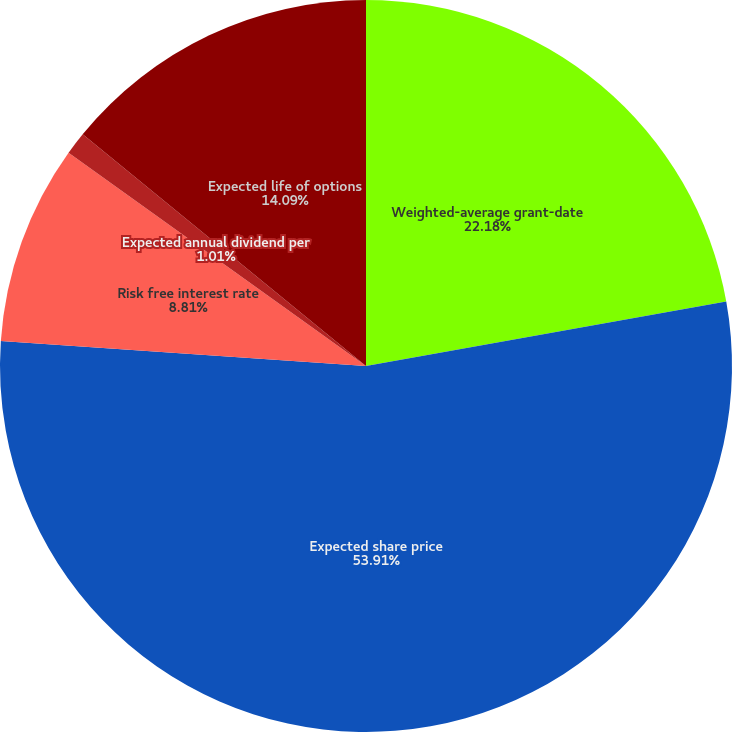<chart> <loc_0><loc_0><loc_500><loc_500><pie_chart><fcel>Weighted-average grant-date<fcel>Expected share price<fcel>Risk free interest rate<fcel>Expected annual dividend per<fcel>Expected life of options<nl><fcel>22.18%<fcel>53.92%<fcel>8.81%<fcel>1.01%<fcel>14.09%<nl></chart> 